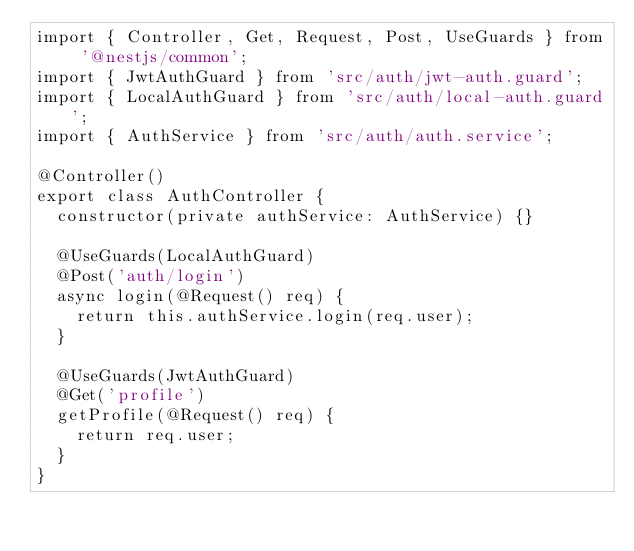Convert code to text. <code><loc_0><loc_0><loc_500><loc_500><_TypeScript_>import { Controller, Get, Request, Post, UseGuards } from '@nestjs/common';
import { JwtAuthGuard } from 'src/auth/jwt-auth.guard';
import { LocalAuthGuard } from 'src/auth/local-auth.guard';
import { AuthService } from 'src/auth/auth.service';

@Controller()
export class AuthController {
  constructor(private authService: AuthService) {}

  @UseGuards(LocalAuthGuard)
  @Post('auth/login')
  async login(@Request() req) {
    return this.authService.login(req.user);
  }

  @UseGuards(JwtAuthGuard)
  @Get('profile')
  getProfile(@Request() req) {
    return req.user;
  }
}</code> 